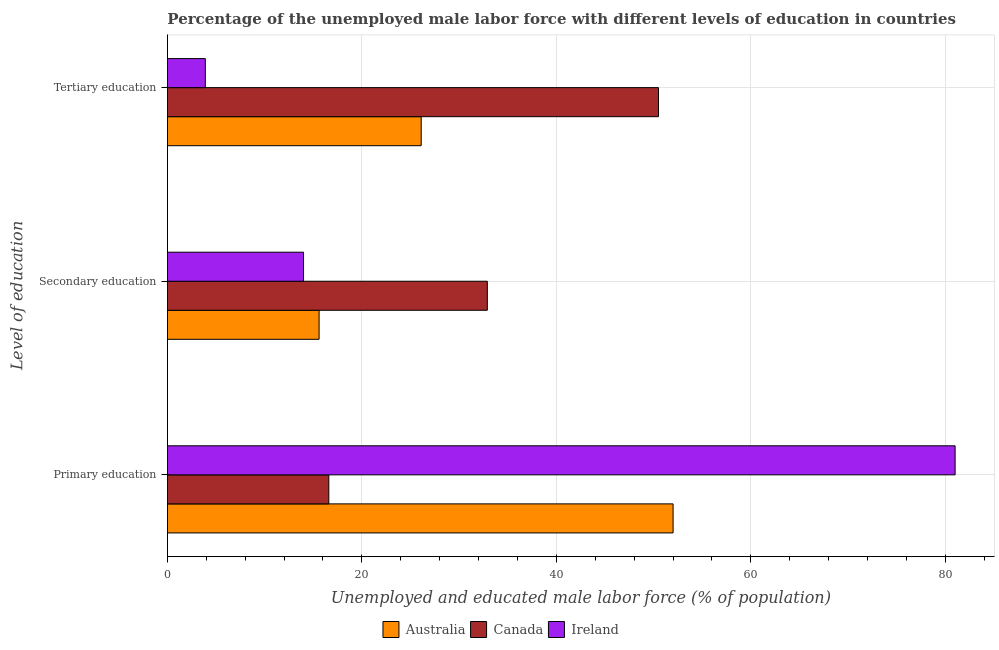How many different coloured bars are there?
Keep it short and to the point. 3. How many groups of bars are there?
Provide a short and direct response. 3. Are the number of bars on each tick of the Y-axis equal?
Provide a succinct answer. Yes. What is the label of the 2nd group of bars from the top?
Offer a terse response. Secondary education. Across all countries, what is the maximum percentage of male labor force who received tertiary education?
Make the answer very short. 50.5. Across all countries, what is the minimum percentage of male labor force who received tertiary education?
Make the answer very short. 3.9. In which country was the percentage of male labor force who received tertiary education maximum?
Give a very brief answer. Canada. What is the total percentage of male labor force who received tertiary education in the graph?
Keep it short and to the point. 80.5. What is the difference between the percentage of male labor force who received secondary education in Australia and that in Ireland?
Offer a very short reply. 1.6. What is the difference between the percentage of male labor force who received secondary education in Ireland and the percentage of male labor force who received tertiary education in Australia?
Ensure brevity in your answer.  -12.1. What is the average percentage of male labor force who received primary education per country?
Offer a very short reply. 49.87. What is the difference between the percentage of male labor force who received secondary education and percentage of male labor force who received primary education in Australia?
Offer a terse response. -36.4. What is the ratio of the percentage of male labor force who received primary education in Ireland to that in Australia?
Your answer should be compact. 1.56. Is the percentage of male labor force who received primary education in Canada less than that in Ireland?
Ensure brevity in your answer.  Yes. Is the difference between the percentage of male labor force who received secondary education in Australia and Ireland greater than the difference between the percentage of male labor force who received tertiary education in Australia and Ireland?
Provide a succinct answer. No. What is the difference between the highest and the second highest percentage of male labor force who received secondary education?
Ensure brevity in your answer.  17.3. What is the difference between the highest and the lowest percentage of male labor force who received primary education?
Provide a succinct answer. 64.4. Is the sum of the percentage of male labor force who received primary education in Australia and Canada greater than the maximum percentage of male labor force who received tertiary education across all countries?
Offer a terse response. Yes. What does the 1st bar from the top in Tertiary education represents?
Give a very brief answer. Ireland. What does the 1st bar from the bottom in Tertiary education represents?
Make the answer very short. Australia. How many countries are there in the graph?
Your answer should be compact. 3. What is the difference between two consecutive major ticks on the X-axis?
Ensure brevity in your answer.  20. Does the graph contain any zero values?
Provide a succinct answer. No. How many legend labels are there?
Give a very brief answer. 3. What is the title of the graph?
Your answer should be very brief. Percentage of the unemployed male labor force with different levels of education in countries. What is the label or title of the X-axis?
Offer a terse response. Unemployed and educated male labor force (% of population). What is the label or title of the Y-axis?
Your response must be concise. Level of education. What is the Unemployed and educated male labor force (% of population) in Canada in Primary education?
Give a very brief answer. 16.6. What is the Unemployed and educated male labor force (% of population) of Ireland in Primary education?
Ensure brevity in your answer.  81. What is the Unemployed and educated male labor force (% of population) in Australia in Secondary education?
Your answer should be compact. 15.6. What is the Unemployed and educated male labor force (% of population) in Canada in Secondary education?
Keep it short and to the point. 32.9. What is the Unemployed and educated male labor force (% of population) in Australia in Tertiary education?
Keep it short and to the point. 26.1. What is the Unemployed and educated male labor force (% of population) of Canada in Tertiary education?
Provide a succinct answer. 50.5. What is the Unemployed and educated male labor force (% of population) in Ireland in Tertiary education?
Your response must be concise. 3.9. Across all Level of education, what is the maximum Unemployed and educated male labor force (% of population) of Australia?
Your response must be concise. 52. Across all Level of education, what is the maximum Unemployed and educated male labor force (% of population) of Canada?
Make the answer very short. 50.5. Across all Level of education, what is the maximum Unemployed and educated male labor force (% of population) of Ireland?
Give a very brief answer. 81. Across all Level of education, what is the minimum Unemployed and educated male labor force (% of population) of Australia?
Provide a succinct answer. 15.6. Across all Level of education, what is the minimum Unemployed and educated male labor force (% of population) of Canada?
Give a very brief answer. 16.6. Across all Level of education, what is the minimum Unemployed and educated male labor force (% of population) of Ireland?
Offer a terse response. 3.9. What is the total Unemployed and educated male labor force (% of population) of Australia in the graph?
Make the answer very short. 93.7. What is the total Unemployed and educated male labor force (% of population) in Canada in the graph?
Your answer should be very brief. 100. What is the total Unemployed and educated male labor force (% of population) of Ireland in the graph?
Offer a terse response. 98.9. What is the difference between the Unemployed and educated male labor force (% of population) of Australia in Primary education and that in Secondary education?
Your answer should be compact. 36.4. What is the difference between the Unemployed and educated male labor force (% of population) of Canada in Primary education and that in Secondary education?
Offer a terse response. -16.3. What is the difference between the Unemployed and educated male labor force (% of population) of Ireland in Primary education and that in Secondary education?
Your answer should be very brief. 67. What is the difference between the Unemployed and educated male labor force (% of population) in Australia in Primary education and that in Tertiary education?
Ensure brevity in your answer.  25.9. What is the difference between the Unemployed and educated male labor force (% of population) of Canada in Primary education and that in Tertiary education?
Offer a terse response. -33.9. What is the difference between the Unemployed and educated male labor force (% of population) in Ireland in Primary education and that in Tertiary education?
Your answer should be compact. 77.1. What is the difference between the Unemployed and educated male labor force (% of population) in Australia in Secondary education and that in Tertiary education?
Keep it short and to the point. -10.5. What is the difference between the Unemployed and educated male labor force (% of population) in Canada in Secondary education and that in Tertiary education?
Provide a short and direct response. -17.6. What is the difference between the Unemployed and educated male labor force (% of population) of Australia in Primary education and the Unemployed and educated male labor force (% of population) of Canada in Secondary education?
Ensure brevity in your answer.  19.1. What is the difference between the Unemployed and educated male labor force (% of population) in Australia in Primary education and the Unemployed and educated male labor force (% of population) in Canada in Tertiary education?
Give a very brief answer. 1.5. What is the difference between the Unemployed and educated male labor force (% of population) in Australia in Primary education and the Unemployed and educated male labor force (% of population) in Ireland in Tertiary education?
Make the answer very short. 48.1. What is the difference between the Unemployed and educated male labor force (% of population) of Canada in Primary education and the Unemployed and educated male labor force (% of population) of Ireland in Tertiary education?
Your answer should be compact. 12.7. What is the difference between the Unemployed and educated male labor force (% of population) in Australia in Secondary education and the Unemployed and educated male labor force (% of population) in Canada in Tertiary education?
Make the answer very short. -34.9. What is the difference between the Unemployed and educated male labor force (% of population) in Australia in Secondary education and the Unemployed and educated male labor force (% of population) in Ireland in Tertiary education?
Your answer should be very brief. 11.7. What is the average Unemployed and educated male labor force (% of population) of Australia per Level of education?
Your answer should be very brief. 31.23. What is the average Unemployed and educated male labor force (% of population) of Canada per Level of education?
Offer a terse response. 33.33. What is the average Unemployed and educated male labor force (% of population) of Ireland per Level of education?
Offer a terse response. 32.97. What is the difference between the Unemployed and educated male labor force (% of population) of Australia and Unemployed and educated male labor force (% of population) of Canada in Primary education?
Provide a succinct answer. 35.4. What is the difference between the Unemployed and educated male labor force (% of population) in Australia and Unemployed and educated male labor force (% of population) in Ireland in Primary education?
Your answer should be compact. -29. What is the difference between the Unemployed and educated male labor force (% of population) in Canada and Unemployed and educated male labor force (% of population) in Ireland in Primary education?
Offer a very short reply. -64.4. What is the difference between the Unemployed and educated male labor force (% of population) of Australia and Unemployed and educated male labor force (% of population) of Canada in Secondary education?
Make the answer very short. -17.3. What is the difference between the Unemployed and educated male labor force (% of population) of Australia and Unemployed and educated male labor force (% of population) of Ireland in Secondary education?
Your answer should be compact. 1.6. What is the difference between the Unemployed and educated male labor force (% of population) of Canada and Unemployed and educated male labor force (% of population) of Ireland in Secondary education?
Your answer should be compact. 18.9. What is the difference between the Unemployed and educated male labor force (% of population) of Australia and Unemployed and educated male labor force (% of population) of Canada in Tertiary education?
Keep it short and to the point. -24.4. What is the difference between the Unemployed and educated male labor force (% of population) of Canada and Unemployed and educated male labor force (% of population) of Ireland in Tertiary education?
Ensure brevity in your answer.  46.6. What is the ratio of the Unemployed and educated male labor force (% of population) in Canada in Primary education to that in Secondary education?
Give a very brief answer. 0.5. What is the ratio of the Unemployed and educated male labor force (% of population) in Ireland in Primary education to that in Secondary education?
Your response must be concise. 5.79. What is the ratio of the Unemployed and educated male labor force (% of population) in Australia in Primary education to that in Tertiary education?
Offer a very short reply. 1.99. What is the ratio of the Unemployed and educated male labor force (% of population) of Canada in Primary education to that in Tertiary education?
Your answer should be very brief. 0.33. What is the ratio of the Unemployed and educated male labor force (% of population) in Ireland in Primary education to that in Tertiary education?
Your response must be concise. 20.77. What is the ratio of the Unemployed and educated male labor force (% of population) in Australia in Secondary education to that in Tertiary education?
Make the answer very short. 0.6. What is the ratio of the Unemployed and educated male labor force (% of population) in Canada in Secondary education to that in Tertiary education?
Your answer should be very brief. 0.65. What is the ratio of the Unemployed and educated male labor force (% of population) in Ireland in Secondary education to that in Tertiary education?
Your answer should be compact. 3.59. What is the difference between the highest and the second highest Unemployed and educated male labor force (% of population) of Australia?
Your answer should be very brief. 25.9. What is the difference between the highest and the lowest Unemployed and educated male labor force (% of population) in Australia?
Give a very brief answer. 36.4. What is the difference between the highest and the lowest Unemployed and educated male labor force (% of population) in Canada?
Your response must be concise. 33.9. What is the difference between the highest and the lowest Unemployed and educated male labor force (% of population) in Ireland?
Keep it short and to the point. 77.1. 